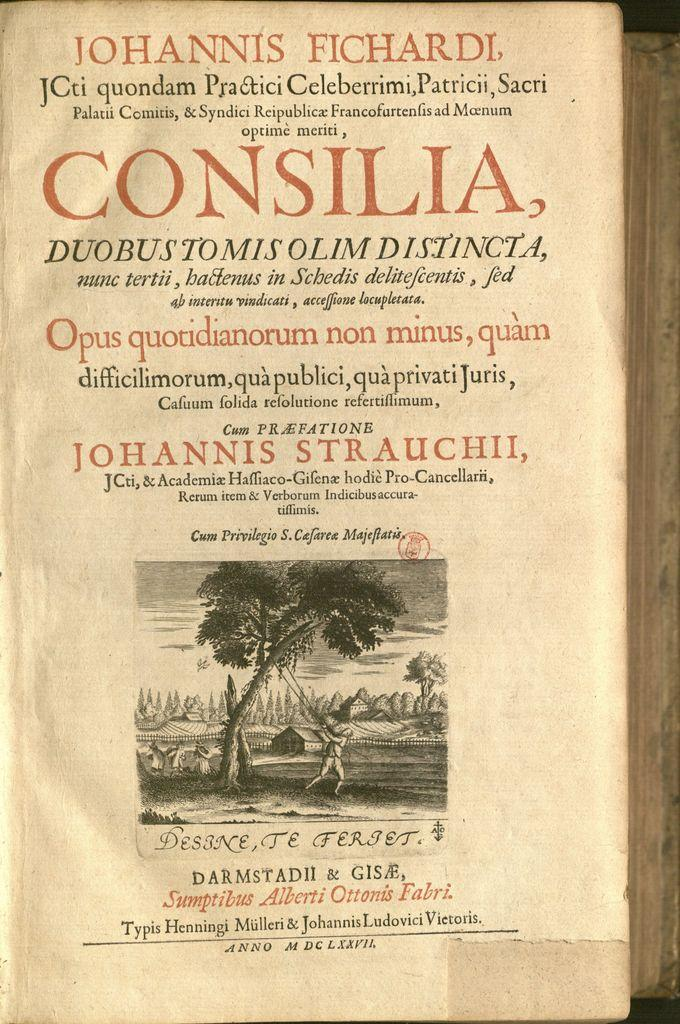<image>
Create a compact narrative representing the image presented. A front cover of a very old book with foreign words is written by Johannis Fichardi. 